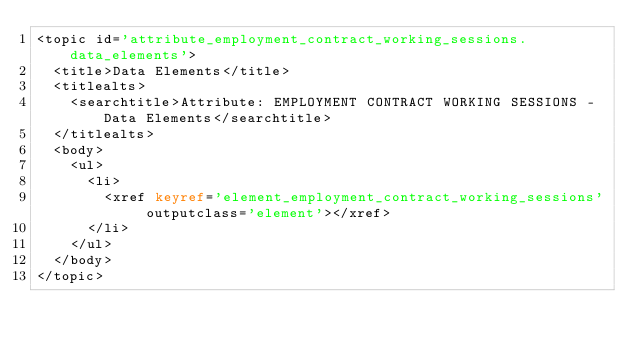<code> <loc_0><loc_0><loc_500><loc_500><_XML_><topic id='attribute_employment_contract_working_sessions.data_elements'>
  <title>Data Elements</title>
  <titlealts>
    <searchtitle>Attribute: EMPLOYMENT CONTRACT WORKING SESSIONS - Data Elements</searchtitle>
  </titlealts>
  <body>
    <ul>
      <li>
        <xref keyref='element_employment_contract_working_sessions' outputclass='element'></xref>
      </li>
    </ul>
  </body>
</topic></code> 